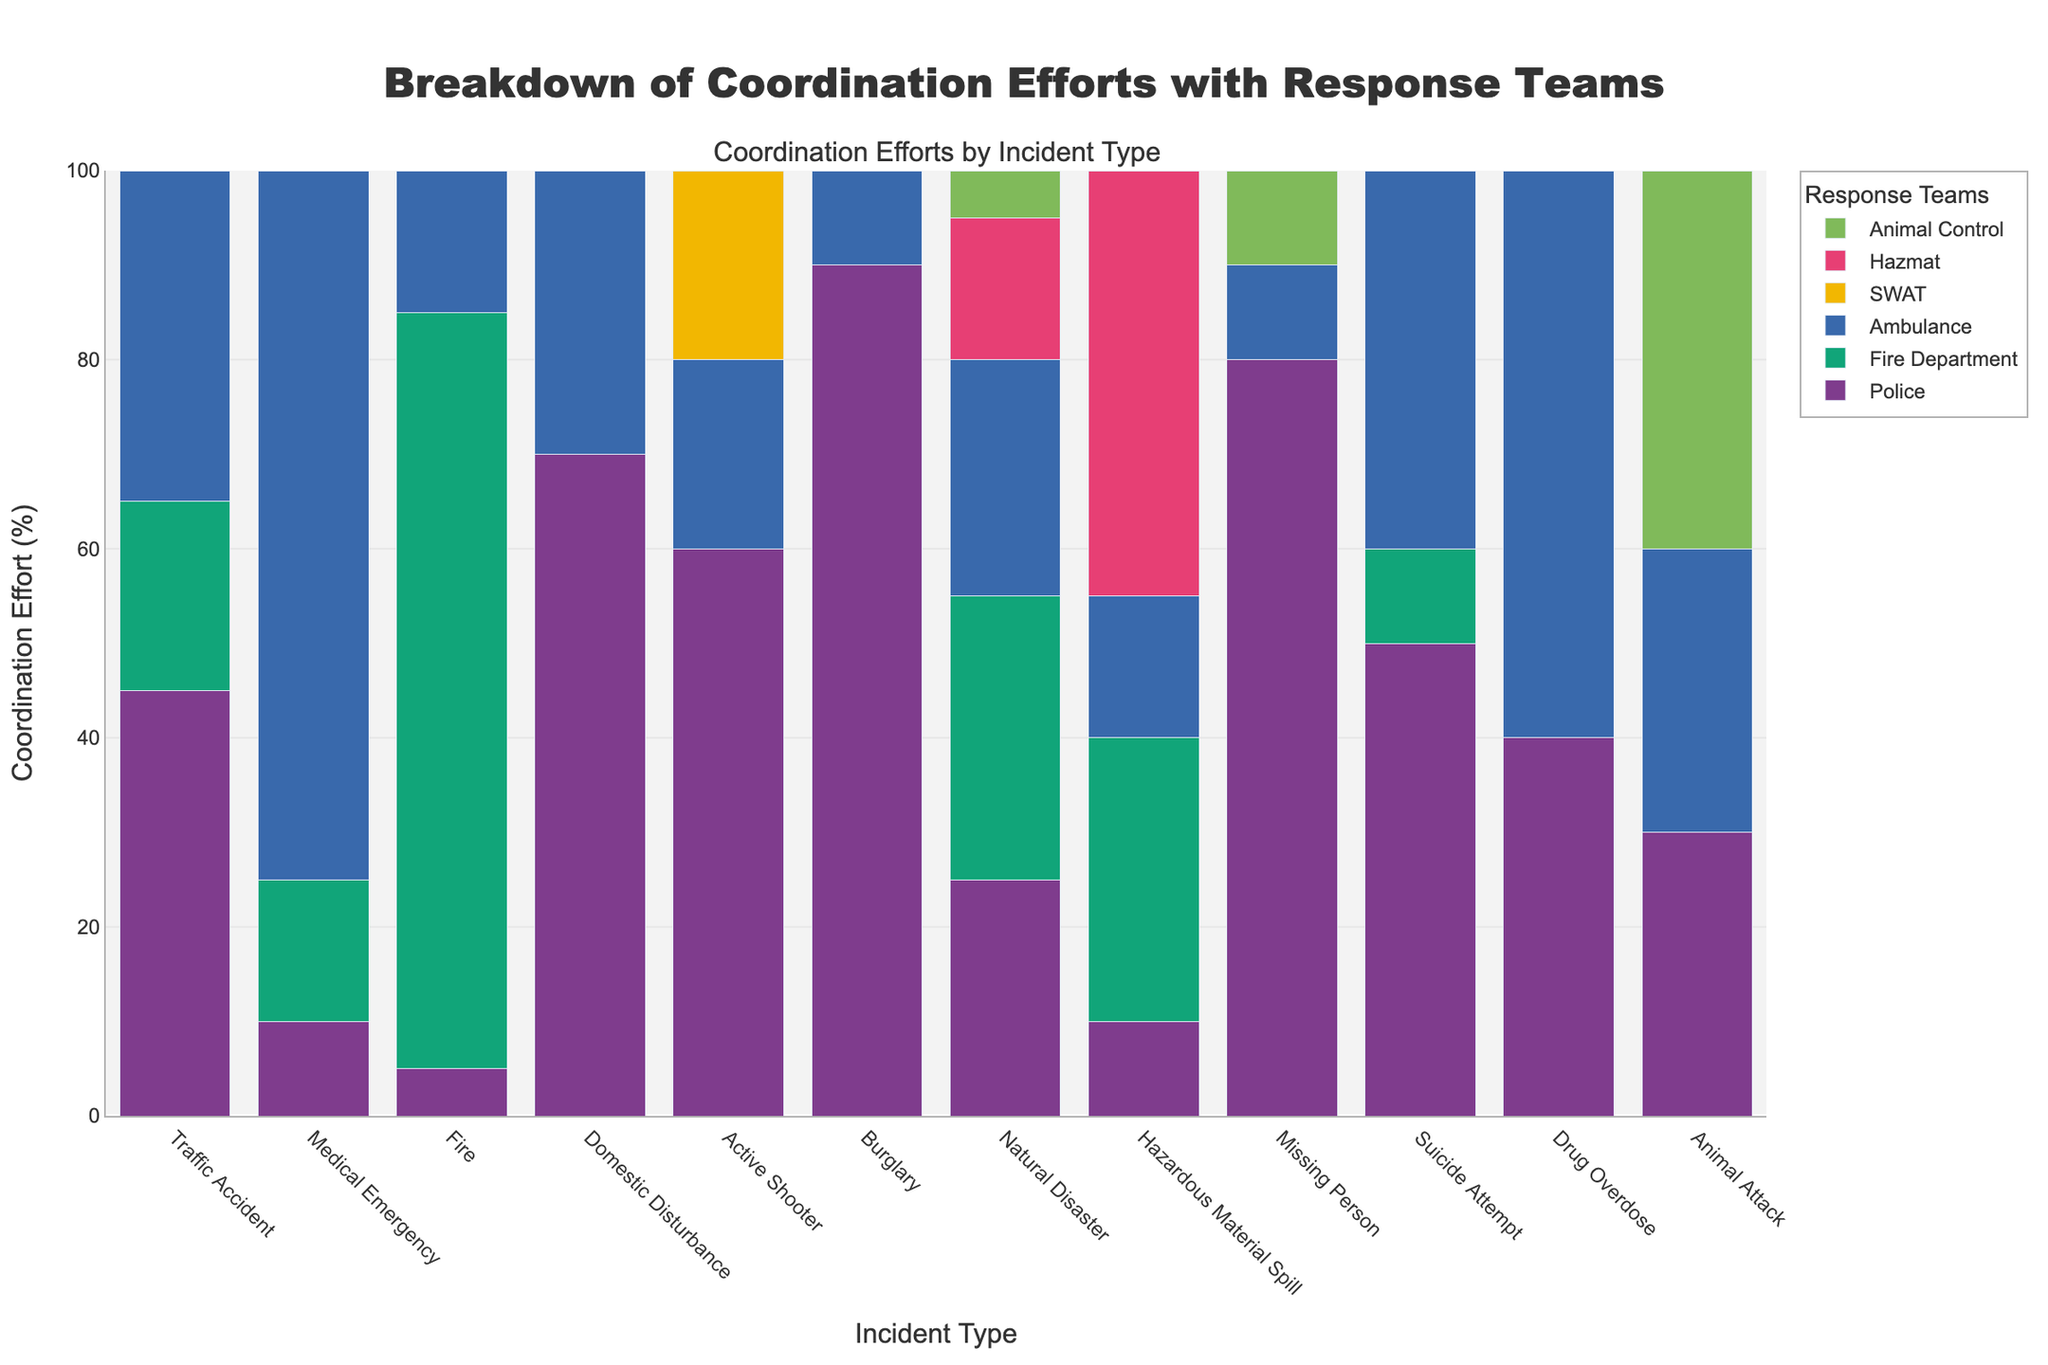Which incident type required the most effort from the Fire Department? Observing the tallest bar in the Fire Department series, the highest coordination effort is for "Fire" incidents.
Answer: Fire Which incident type involved both the Police and SWAT teams? Check for incidents where both Police and SWAT bars are present. The "Active Shooter" incident involves both.
Answer: Active Shooter How many total response teams are involved in a Natural Disaster? Sum the coordination efforts for each response team in the data for "Natural Disaster". Police: 25, Fire Department: 30, Ambulance: 25, Hazmat: 15, Animal Control: 5. Total is 25 + 30 + 25 + 15 + 5.
Answer: 100 On average, how many incidents required coordination with Hazmat? Divide the total coordination efforts of Hazmat among all incident types where it is involved. Incidents: Natural Disaster (15) and Hazardous Material Spill (45). Total efforts: 15 + 45 = 60. Number of incidents = 2. Average = 60 / 2.
Answer: 30 Which incident type required the least effort from the Ambulance? By comparing the shortest bars under the Ambulance category, "Burglary" shows the least effort.
Answer: Burglary Is the coordination effort for Traffic Accidents greater or smaller than Medical Emergencies for the Police team? Compare the height of the "Police" bars for "Traffic Accident" (45) and "Medical Emergency" (10). 45 is greater than 10.
Answer: Greater What is the difference in effort between the Police and the Fire Department for Traffic Accidents? Subtract Fire Department effort from Police effort for Traffic Accidents. Police: 45, Fire Department: 20. Difference = 45 - 20.
Answer: 25 Which incident type had equal coordination efforts from Animal Control and the Ambulance? Find where the bars for Animal Control and Ambulance are equal. This happens in "Animal Attack", both being 30.
Answer: Animal Attack How many incident types involved coordination with the Police but not Animal Control? Count incidents with coordination efforts for Police depicted but no bar for Animal Control. These are Traffic Accident, Medical Emergency, Fire, Domestic Disturbance, Active Shooter, Burglary, Natural Disaster, Hazardous Material Spill, Suicide Attempt, Drug Overdose, and Missing Person (11 total). Subtract the one that involves Animal Control (Missing Person), 11 - 1.
Answer: 10 